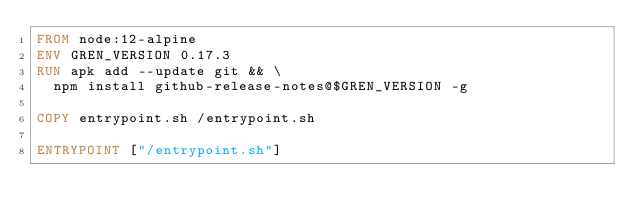Convert code to text. <code><loc_0><loc_0><loc_500><loc_500><_Dockerfile_>FROM node:12-alpine
ENV GREN_VERSION 0.17.3
RUN apk add --update git && \
  npm install github-release-notes@$GREN_VERSION -g

COPY entrypoint.sh /entrypoint.sh

ENTRYPOINT ["/entrypoint.sh"]
</code> 